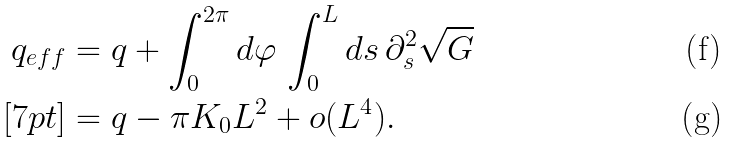Convert formula to latex. <formula><loc_0><loc_0><loc_500><loc_500>q _ { e f f } & = q + \int _ { 0 } ^ { 2 \pi } d \varphi \, \int _ { 0 } ^ { L } d s \, \partial _ { s } ^ { 2 } \sqrt { G } \\ [ 7 p t ] & = q - \pi K _ { 0 } L ^ { 2 } + o ( L ^ { 4 } ) .</formula> 